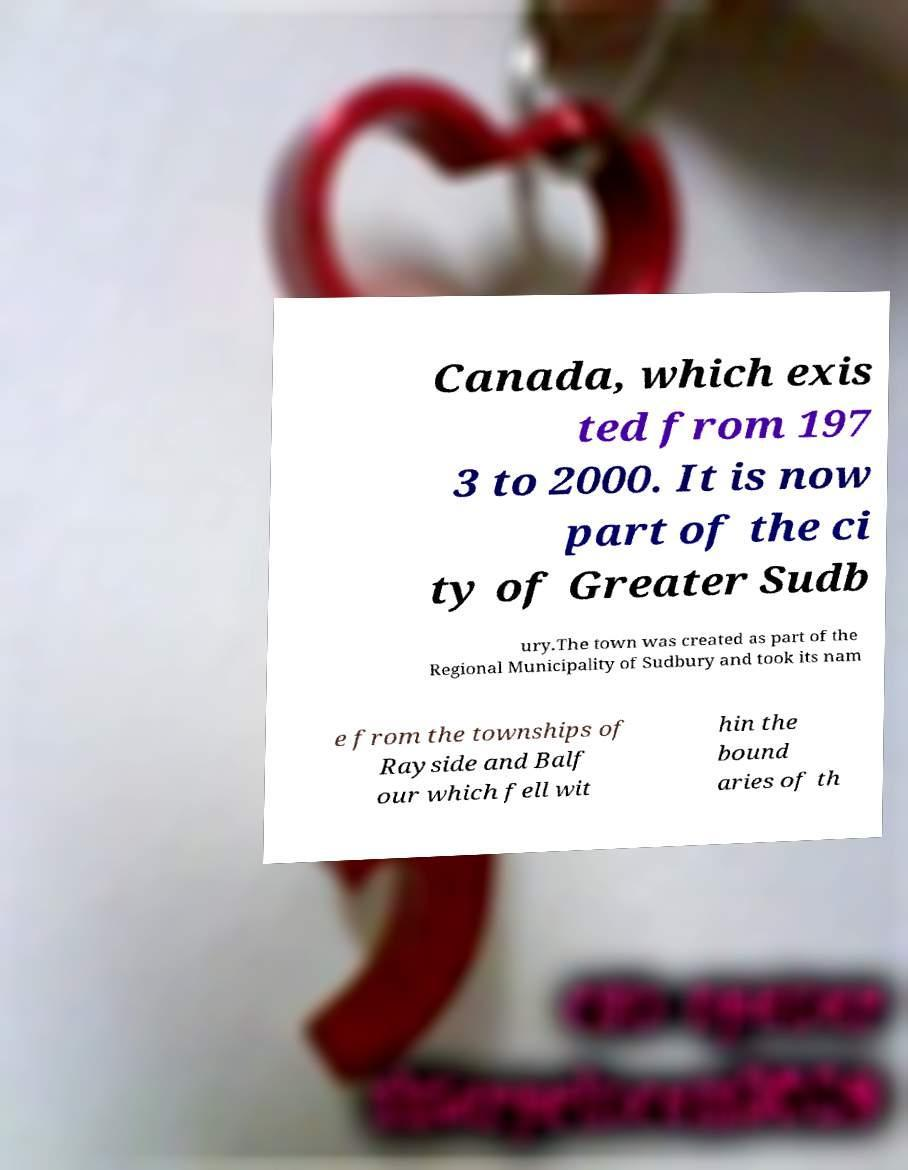For documentation purposes, I need the text within this image transcribed. Could you provide that? Canada, which exis ted from 197 3 to 2000. It is now part of the ci ty of Greater Sudb ury.The town was created as part of the Regional Municipality of Sudbury and took its nam e from the townships of Rayside and Balf our which fell wit hin the bound aries of th 